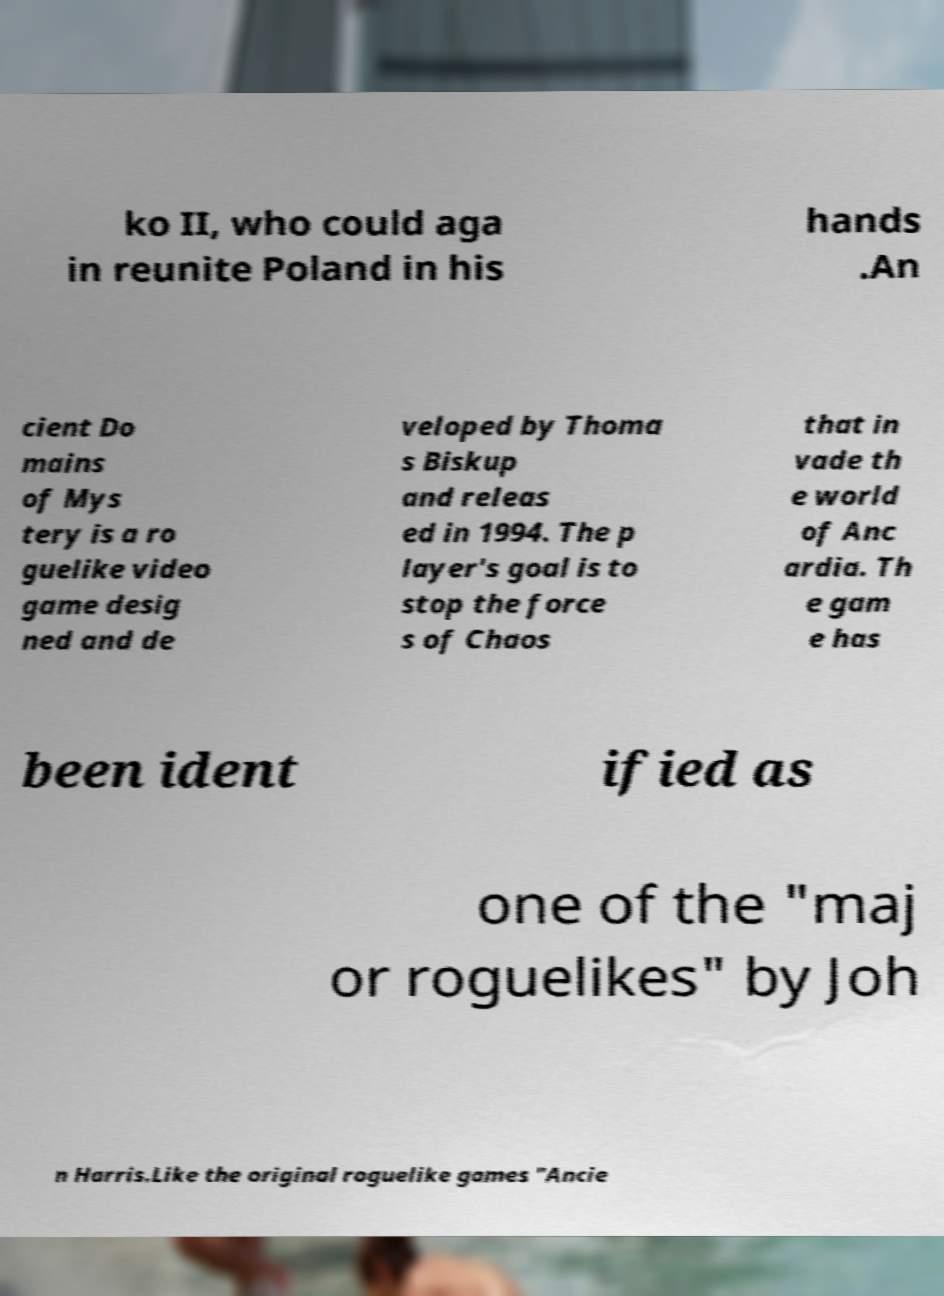Could you extract and type out the text from this image? ko II, who could aga in reunite Poland in his hands .An cient Do mains of Mys tery is a ro guelike video game desig ned and de veloped by Thoma s Biskup and releas ed in 1994. The p layer's goal is to stop the force s of Chaos that in vade th e world of Anc ardia. Th e gam e has been ident ified as one of the "maj or roguelikes" by Joh n Harris.Like the original roguelike games "Ancie 